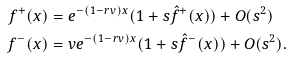<formula> <loc_0><loc_0><loc_500><loc_500>f ^ { + } ( x ) & = e ^ { - ( 1 - r v ) x } ( 1 + s \hat { f } ^ { + } ( x ) ) + O ( s ^ { 2 } ) \\ f ^ { - } ( x ) & = v e ^ { - ( 1 - r v ) x } ( 1 + s \hat { f } ^ { - } ( x ) ) + O ( s ^ { 2 } ) .</formula> 